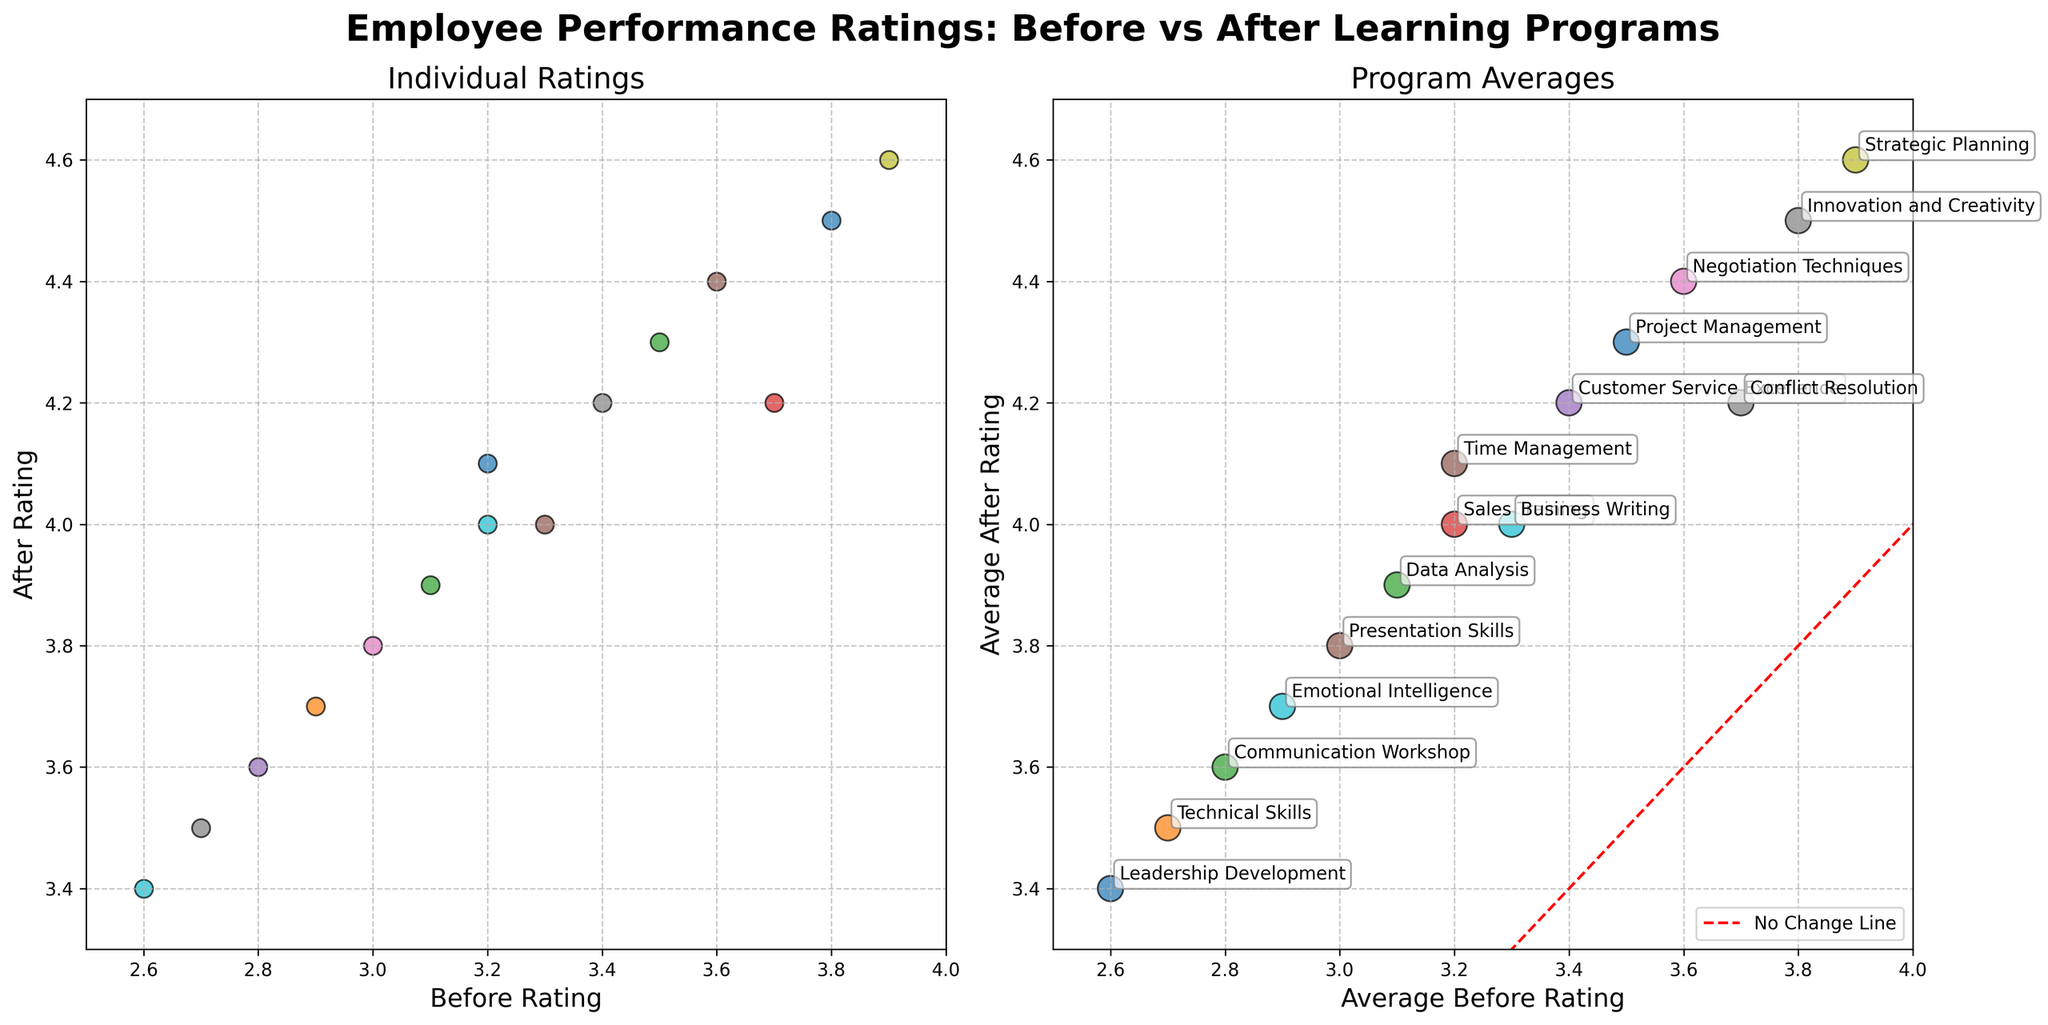What is the title of the figure? The title is displayed at the top of the figure in bold text. It reads "Employee Performance Ratings: Before vs After Learning Programs."
Answer: Employee Performance Ratings: Before vs After Learning Programs How many subplots are displayed in the figure? There are two separate plots within the figure, each displaying different visual information.
Answer: Two What is the axis label for the x-axis on the first subplot? The x-axis on the first subplot is labeled "Before Rating."
Answer: Before Rating Which learning program has the highest average after rating? To determine this, look at the second subplot depicting "Program Averages" and observe which program has its average after rating highest on the y-axis. "Strategic Planning" appears to have the highest average after rating.
Answer: Strategic Planning On the first subplot, what range is used for the y-axis? The y-axis range for the first subplot can be seen by checking the lowest and highest values marked on the y-axis. It ranges from 3.3 to 4.7.
Answer: 3.3 to 4.7 Is there a visible correlation between before ratings and after ratings in the individual ratings plot? To determine if there's a correlation, observe the distribution of the scatter points. The points generally form an upward trend, indicating a positive correlation.
Answer: Yes Which learning program shows a notable improvement in average performance rating? Locate the two points, one on each axis, for each program on the second subplot. Compare the initial and post-program averages; "Emotional Intelligence," for instance, shows a significant increase from its starting point.
Answer: Emotional Intelligence How do the before and after ratings for the "Technical Skills" program compare? On the second subplot, check the 'Technical Skills' program's position. It shows an average before rating lower than the after rating, indicating an improvement.
Answer: After rating is higher than before rating Which subplot has a reference line, and what is its purpose? The second subplot (Program Averages) includes a red dashed line. It signifies the "No Change Line," representing where the before and after ratings would be equal, helping to visualize improvements.
Answer: The second subplot; to show no change Are there more programs where the average rating increased or decreased after the implementation of the learning programs? Check the position of each program's average ratings in the second subplot relative to the red dashed line. Most programs' points lie above this line, showing an increase.
Answer: Increased 